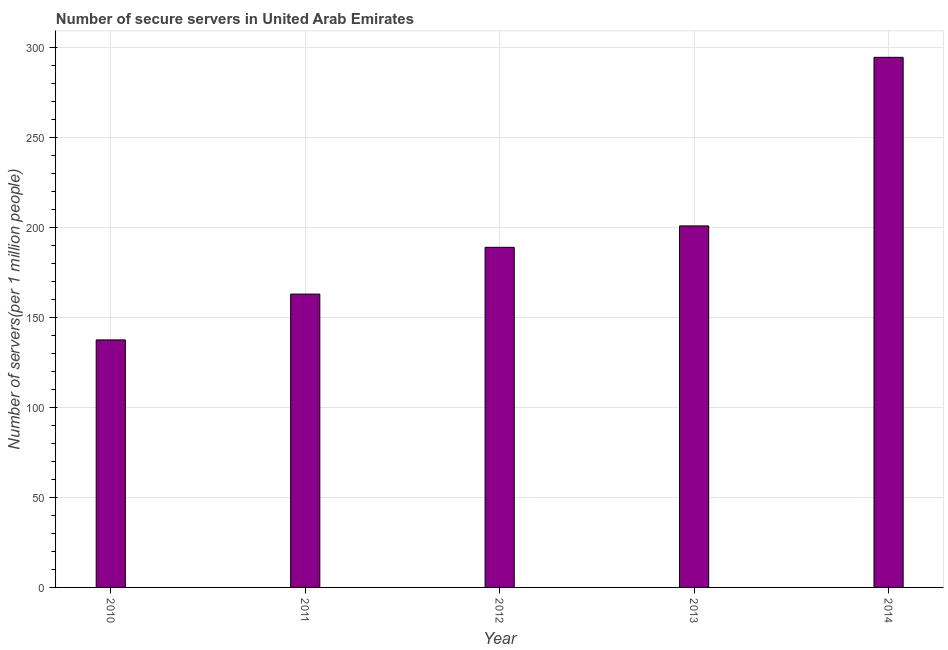What is the title of the graph?
Provide a succinct answer. Number of secure servers in United Arab Emirates. What is the label or title of the X-axis?
Your answer should be very brief. Year. What is the label or title of the Y-axis?
Provide a succinct answer. Number of servers(per 1 million people). What is the number of secure internet servers in 2013?
Provide a short and direct response. 200.77. Across all years, what is the maximum number of secure internet servers?
Provide a short and direct response. 294.4. Across all years, what is the minimum number of secure internet servers?
Provide a succinct answer. 137.46. In which year was the number of secure internet servers maximum?
Make the answer very short. 2014. In which year was the number of secure internet servers minimum?
Your answer should be very brief. 2010. What is the sum of the number of secure internet servers?
Provide a succinct answer. 984.44. What is the difference between the number of secure internet servers in 2010 and 2014?
Offer a very short reply. -156.94. What is the average number of secure internet servers per year?
Ensure brevity in your answer.  196.89. What is the median number of secure internet servers?
Your answer should be very brief. 188.88. In how many years, is the number of secure internet servers greater than 110 ?
Your response must be concise. 5. What is the ratio of the number of secure internet servers in 2013 to that in 2014?
Your answer should be compact. 0.68. Is the number of secure internet servers in 2011 less than that in 2013?
Your answer should be compact. Yes. What is the difference between the highest and the second highest number of secure internet servers?
Offer a very short reply. 93.63. What is the difference between the highest and the lowest number of secure internet servers?
Keep it short and to the point. 156.94. In how many years, is the number of secure internet servers greater than the average number of secure internet servers taken over all years?
Make the answer very short. 2. How many years are there in the graph?
Give a very brief answer. 5. What is the difference between two consecutive major ticks on the Y-axis?
Ensure brevity in your answer.  50. Are the values on the major ticks of Y-axis written in scientific E-notation?
Make the answer very short. No. What is the Number of servers(per 1 million people) of 2010?
Offer a terse response. 137.46. What is the Number of servers(per 1 million people) of 2011?
Provide a succinct answer. 162.91. What is the Number of servers(per 1 million people) of 2012?
Offer a terse response. 188.88. What is the Number of servers(per 1 million people) of 2013?
Keep it short and to the point. 200.77. What is the Number of servers(per 1 million people) in 2014?
Your response must be concise. 294.4. What is the difference between the Number of servers(per 1 million people) in 2010 and 2011?
Your response must be concise. -25.45. What is the difference between the Number of servers(per 1 million people) in 2010 and 2012?
Your answer should be very brief. -51.42. What is the difference between the Number of servers(per 1 million people) in 2010 and 2013?
Make the answer very short. -63.31. What is the difference between the Number of servers(per 1 million people) in 2010 and 2014?
Give a very brief answer. -156.94. What is the difference between the Number of servers(per 1 million people) in 2011 and 2012?
Your response must be concise. -25.97. What is the difference between the Number of servers(per 1 million people) in 2011 and 2013?
Keep it short and to the point. -37.86. What is the difference between the Number of servers(per 1 million people) in 2011 and 2014?
Ensure brevity in your answer.  -131.49. What is the difference between the Number of servers(per 1 million people) in 2012 and 2013?
Give a very brief answer. -11.89. What is the difference between the Number of servers(per 1 million people) in 2012 and 2014?
Offer a terse response. -105.52. What is the difference between the Number of servers(per 1 million people) in 2013 and 2014?
Your answer should be compact. -93.63. What is the ratio of the Number of servers(per 1 million people) in 2010 to that in 2011?
Provide a short and direct response. 0.84. What is the ratio of the Number of servers(per 1 million people) in 2010 to that in 2012?
Provide a succinct answer. 0.73. What is the ratio of the Number of servers(per 1 million people) in 2010 to that in 2013?
Your response must be concise. 0.69. What is the ratio of the Number of servers(per 1 million people) in 2010 to that in 2014?
Provide a succinct answer. 0.47. What is the ratio of the Number of servers(per 1 million people) in 2011 to that in 2012?
Provide a succinct answer. 0.86. What is the ratio of the Number of servers(per 1 million people) in 2011 to that in 2013?
Ensure brevity in your answer.  0.81. What is the ratio of the Number of servers(per 1 million people) in 2011 to that in 2014?
Your answer should be very brief. 0.55. What is the ratio of the Number of servers(per 1 million people) in 2012 to that in 2013?
Make the answer very short. 0.94. What is the ratio of the Number of servers(per 1 million people) in 2012 to that in 2014?
Offer a terse response. 0.64. What is the ratio of the Number of servers(per 1 million people) in 2013 to that in 2014?
Keep it short and to the point. 0.68. 